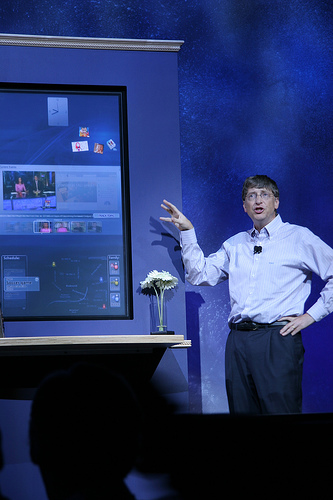<image>
Is there a flower on the man? No. The flower is not positioned on the man. They may be near each other, but the flower is not supported by or resting on top of the man. 